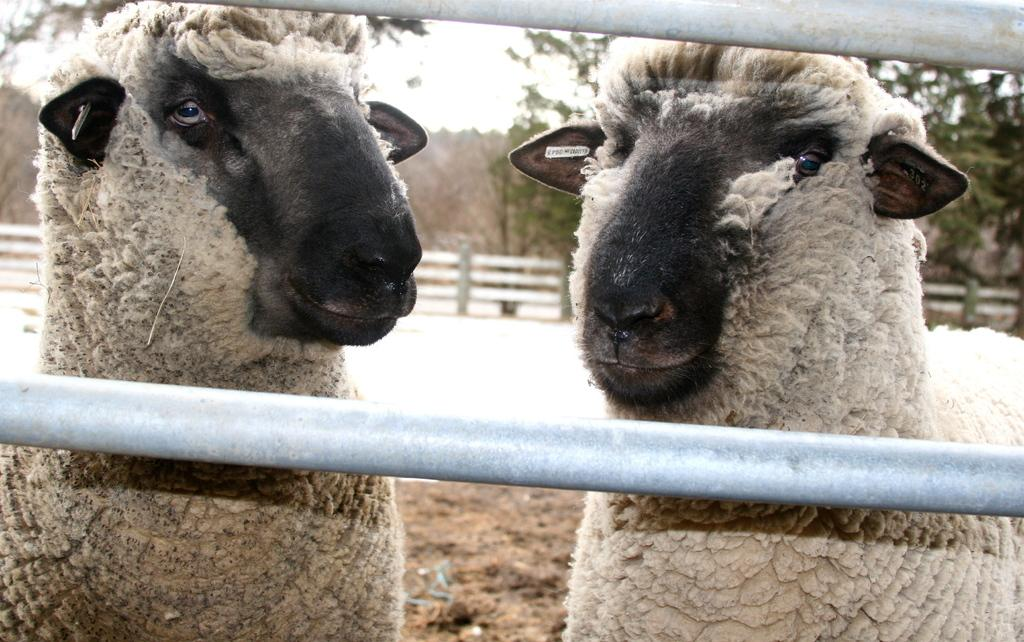What objects can be seen in the image? There are rods and sheep in the image. What is the condition of the background in the image? The background of the image is blurry. What can be seen in the background of the image? There is a fence, trees, and the sky visible in the background of the image. How many frogs are sitting on the rods in the image? There are no frogs present in the image; it features rods and sheep. What type of waste can be seen in the image? There is no waste present in the image. 